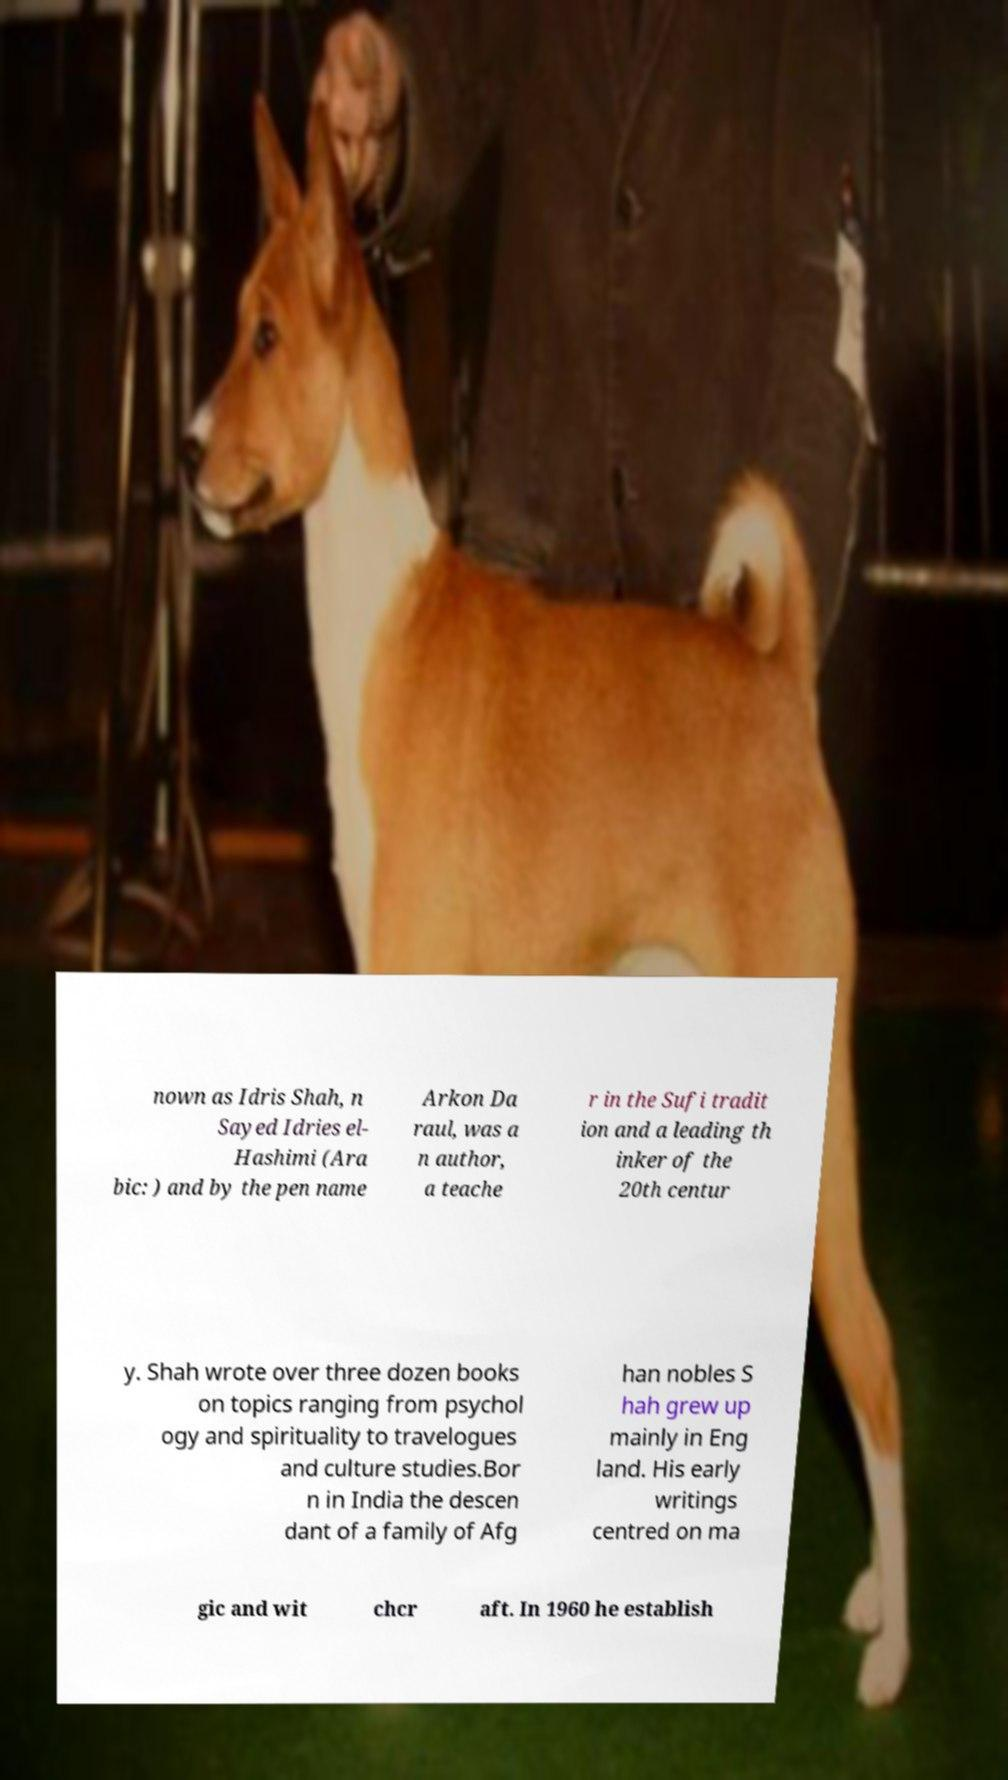Can you accurately transcribe the text from the provided image for me? nown as Idris Shah, n Sayed Idries el- Hashimi (Ara bic: ) and by the pen name Arkon Da raul, was a n author, a teache r in the Sufi tradit ion and a leading th inker of the 20th centur y. Shah wrote over three dozen books on topics ranging from psychol ogy and spirituality to travelogues and culture studies.Bor n in India the descen dant of a family of Afg han nobles S hah grew up mainly in Eng land. His early writings centred on ma gic and wit chcr aft. In 1960 he establish 